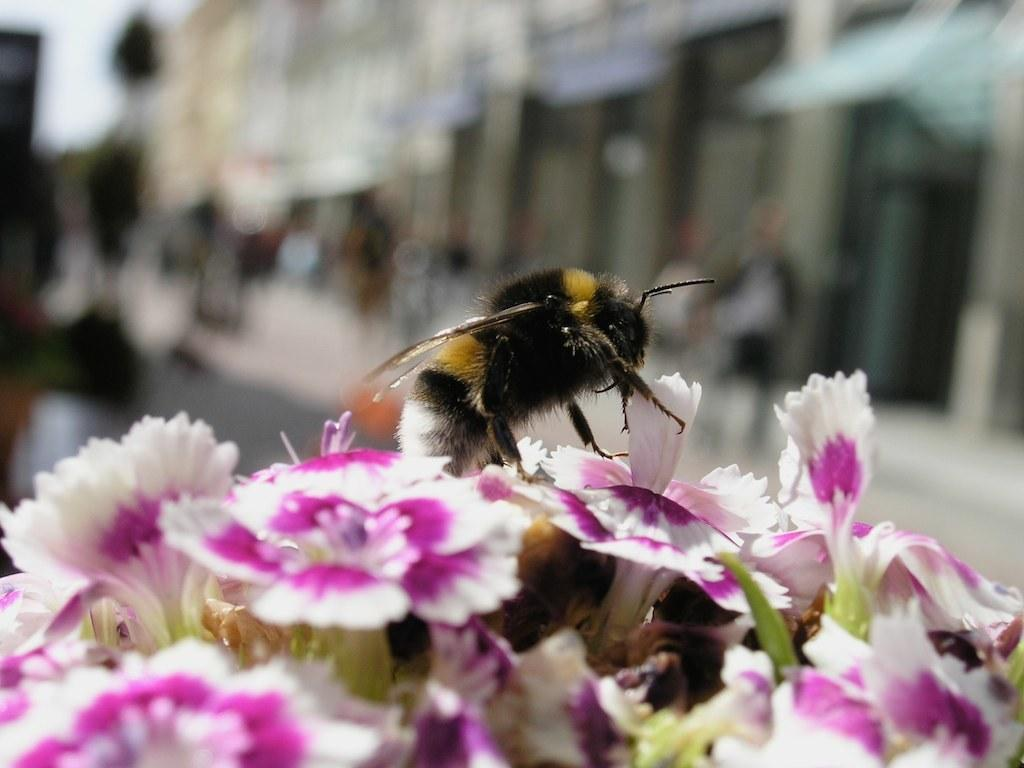What is the main subject of the picture? The main subject of the picture is an insect. Where is the insect located in the image? The insect is on flowers. What colors are the flowers in the image? The flowers are in white and purple colors. How would you describe the background of the image? The background of the image is blurred. How many chickens can be seen in the image? There are no chickens present in the image. Is there a lamp visible in the image? There is no lamp present in the image. 